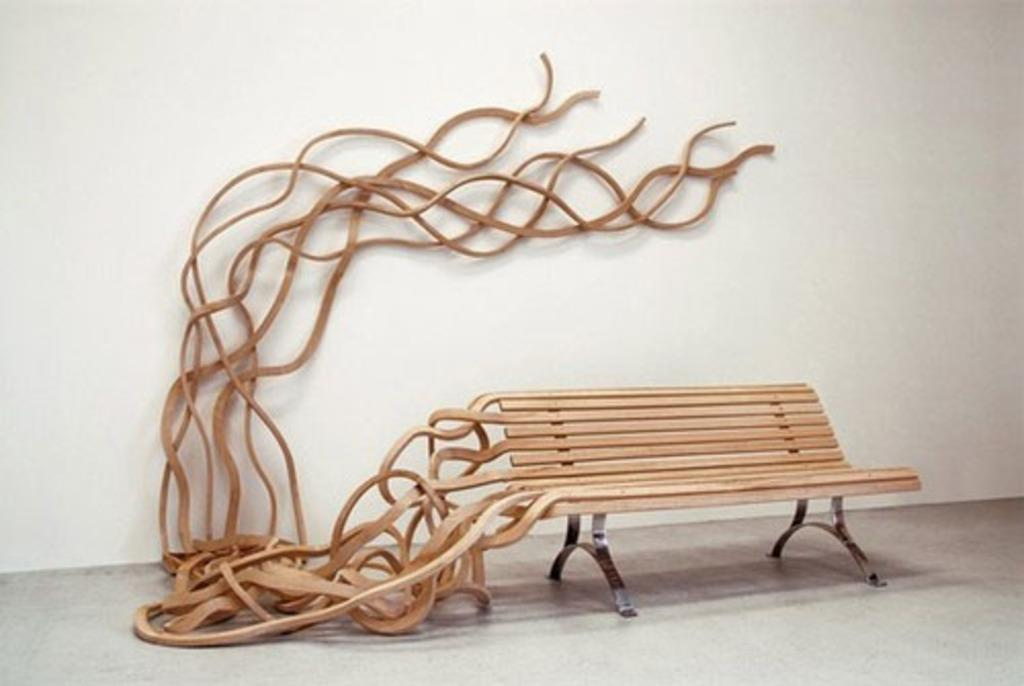What type of furniture is present in the image? There is a designed wooden bench in the image. On what surface is the bench placed? The bench is on a surface. What is visible in the background of the image? There is a wall in the image. What type of heart-shaped object can be seen on the bench in the image? There is no heart-shaped object present on the bench in the image. 